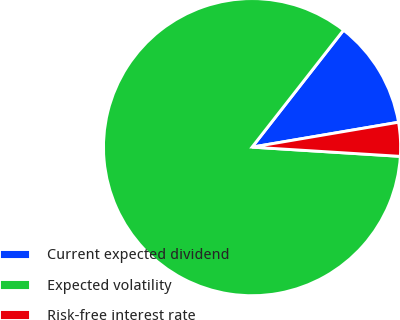<chart> <loc_0><loc_0><loc_500><loc_500><pie_chart><fcel>Current expected dividend<fcel>Expected volatility<fcel>Risk-free interest rate<nl><fcel>11.76%<fcel>84.58%<fcel>3.67%<nl></chart> 